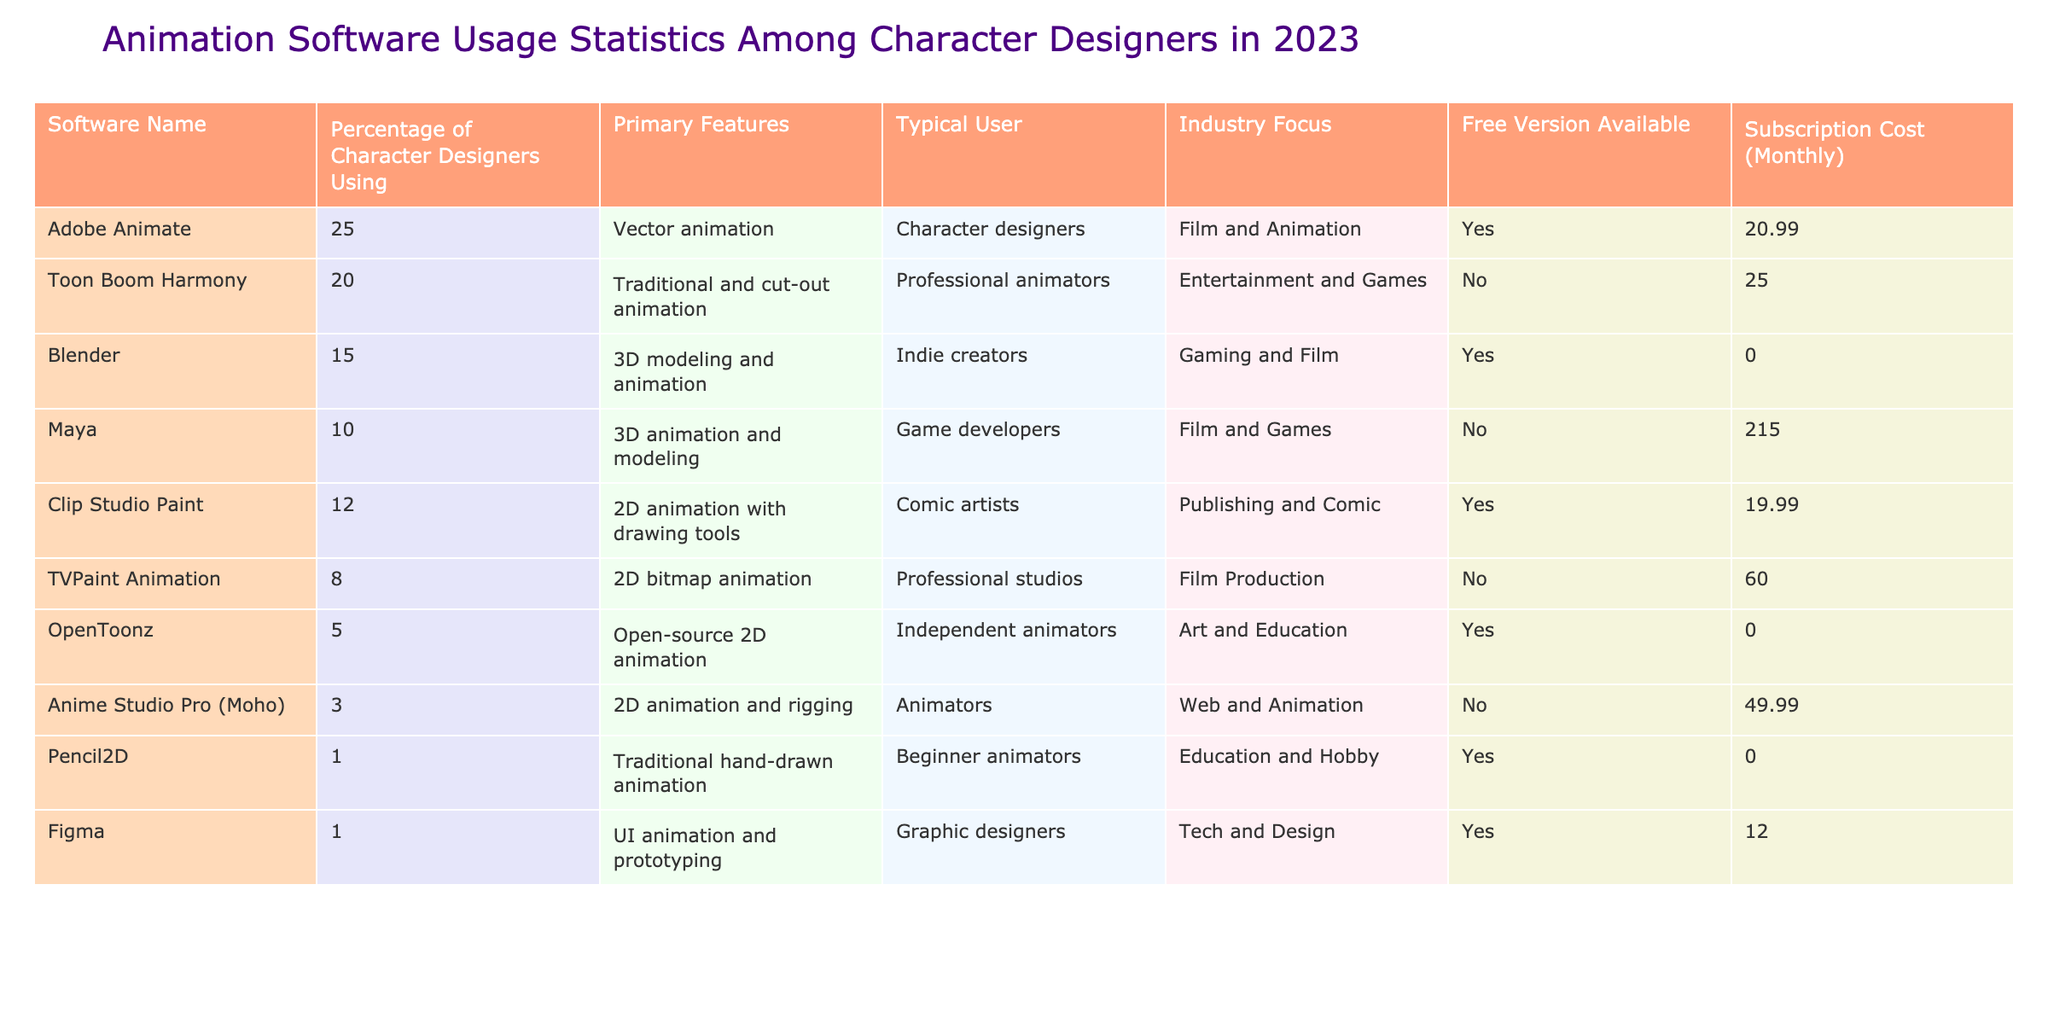What percentage of character designers use Adobe Animate? The table lists the percentage of character designers using each software. For Adobe Animate, the value provided is 25%.
Answer: 25% Which software has the highest subscription cost? By looking at the subscription costs in the table, we find that Maya has the highest cost at $215.00 per month.
Answer: $215.00 Is there a free version available for Blender? The table indicates the availability of a free version for each software. For Blender, it shows 'Yes'.
Answer: Yes What is the average subscription cost of all the listed software? To find the average, we need to add the subscription costs: $20.99 + $25.00 + $0.00 + $215.00 + $19.99 + $60.00 + $0.00 + $49.99 + $0.00 + $12.00 = $404.97. There are 10 software options, so the average is $404.97 / 10 = $40.50.
Answer: $40.50 Which software is primarily focused on artistic education? The table lists 'OpenToonz' under the 'Industry Focus' as 'Art and Education', indicating this software's primary focus.
Answer: OpenToonz What is the percentage difference in users between Toon Boom Harmony and Clip Studio Paint? Toon Boom Harmony users account for 20%, and Clip Studio Paint users are at 12%. The difference is 20% - 12% = 8%.
Answer: 8% Are there more character designers using Adobe Animate or Toon Boom Harmony? According to the table, Adobe Animate has 25% of character designers using it, while Toon Boom Harmony has 20%. Since 25% is greater than 20%, more designers use Adobe Animate.
Answer: Adobe Animate How many software titles have a subscription cost less than $50? Reviewing the subscription costs, the software titles below $50 are Adobe Animate ($20.99), Clip Studio Paint ($19.99), Anime Studio Pro ($49.99), and Figma ($12.00). That's a total of 4 titles.
Answer: 4 What is the industry focus for software that has a free version available? By checking the table for software with a free version ('Yes'), we find their industry focuses: Blender (Gaming and Film), Clip Studio Paint (Publishing and Comic), OpenToonz (Art and Education), Pencil2D (Education and Hobby), and Figma (Tech and Design).
Answer: Multiple industries Which software is used the least among character designers based on percentage? The table states that Pencil2D is used by only 1% of character designers, making it the least used.
Answer: Pencil2D 